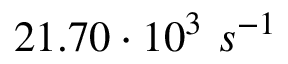<formula> <loc_0><loc_0><loc_500><loc_500>2 1 . 7 0 \cdot 1 0 ^ { 3 } \ s ^ { - 1 }</formula> 